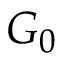Convert formula to latex. <formula><loc_0><loc_0><loc_500><loc_500>G _ { 0 }</formula> 